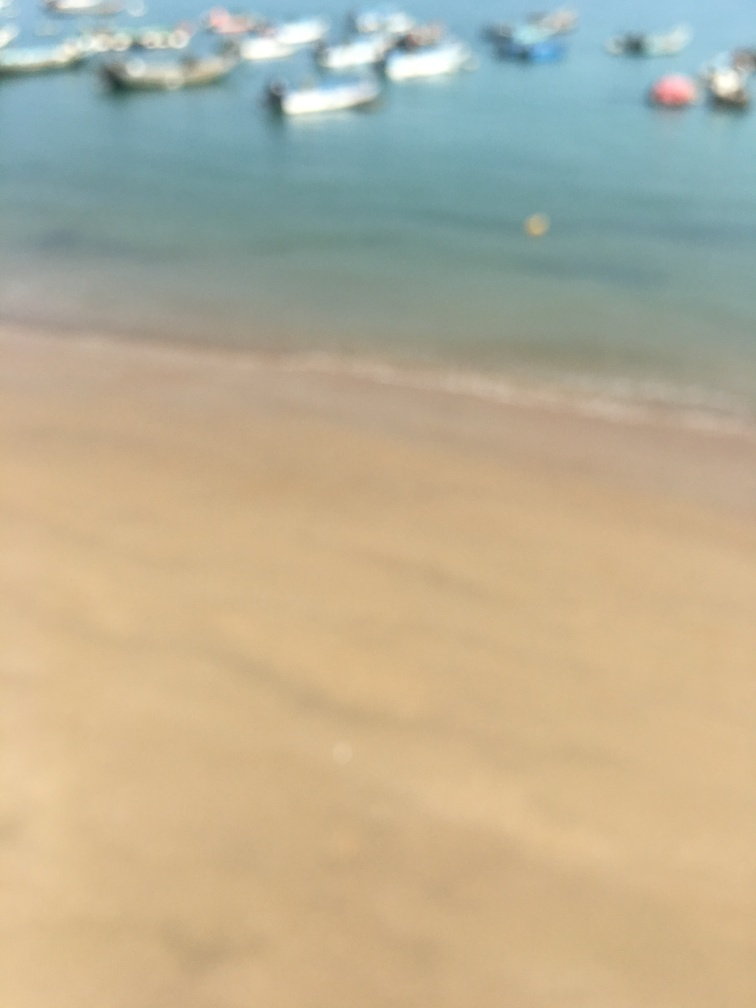Can you tell what time of day it might be in this image? While the blurriness makes it challenging to determine the precise time of day, the brightness and the color of the light suggest it could possibly be midday or early afternoon. 